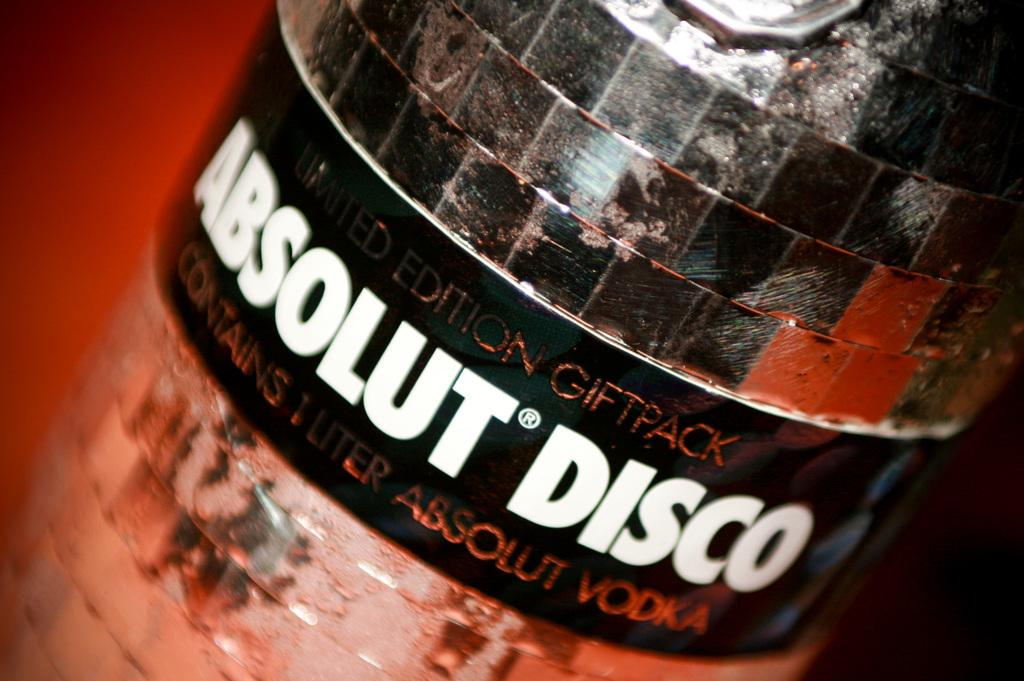<image>
Give a short and clear explanation of the subsequent image. An Absolut Disco logo is on the side of a mirrored bottle. 